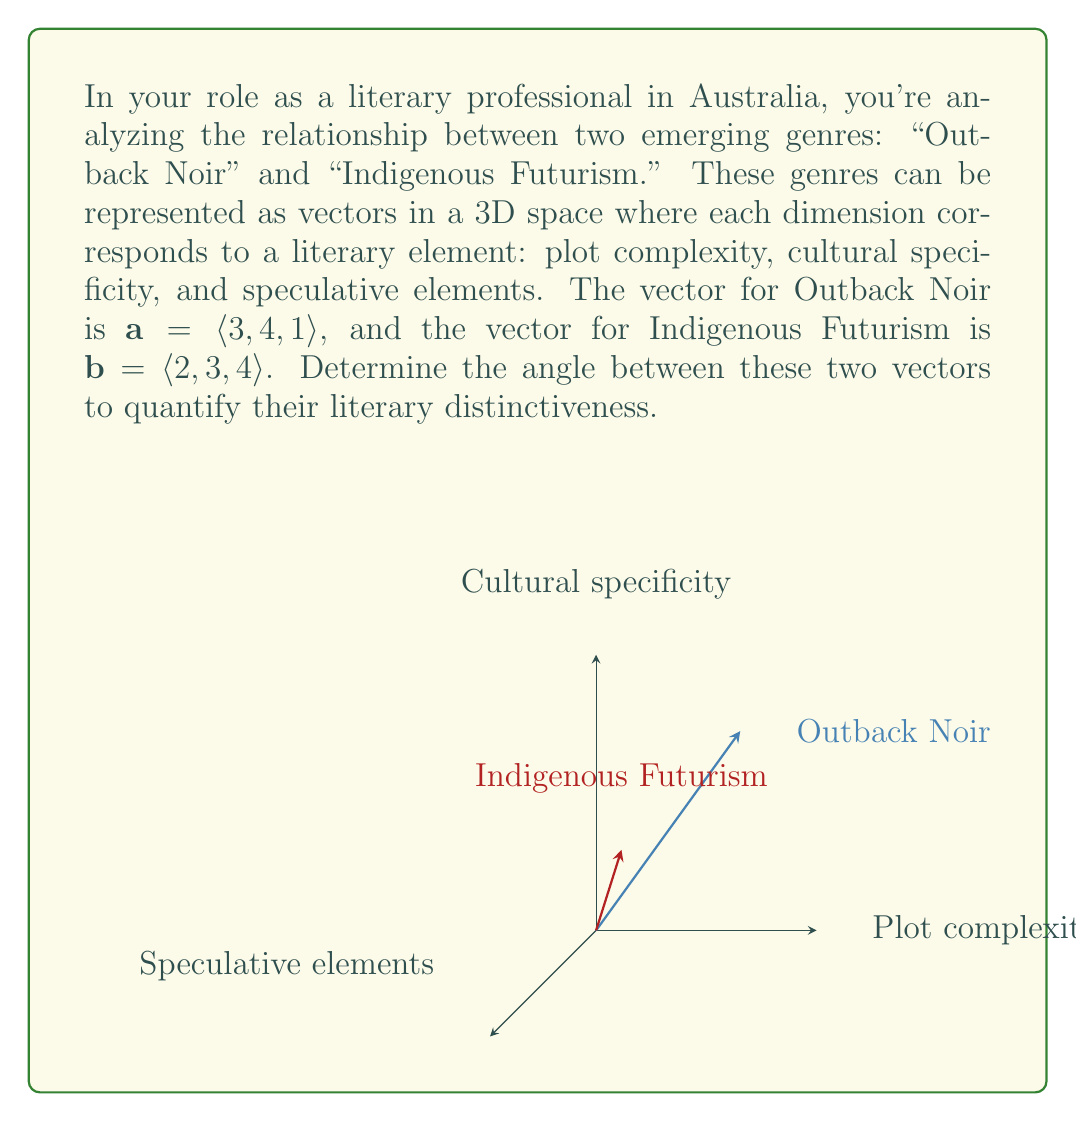Teach me how to tackle this problem. To find the angle between two vectors, we can use the dot product formula:

$$\cos \theta = \frac{\mathbf{a} \cdot \mathbf{b}}{|\mathbf{a}||\mathbf{b}|}$$

Step 1: Calculate the dot product $\mathbf{a} \cdot \mathbf{b}$
$$\mathbf{a} \cdot \mathbf{b} = (3)(2) + (4)(3) + (1)(4) = 6 + 12 + 4 = 22$$

Step 2: Calculate the magnitudes of vectors $\mathbf{a}$ and $\mathbf{b}$
$$|\mathbf{a}| = \sqrt{3^2 + 4^2 + 1^2} = \sqrt{9 + 16 + 1} = \sqrt{26}$$
$$|\mathbf{b}| = \sqrt{2^2 + 3^2 + 4^2} = \sqrt{4 + 9 + 16} = \sqrt{29}$$

Step 3: Apply the dot product formula
$$\cos \theta = \frac{22}{\sqrt{26}\sqrt{29}}$$

Step 4: Calculate the angle using the inverse cosine function
$$\theta = \arccos\left(\frac{22}{\sqrt{26}\sqrt{29}}\right)$$

Step 5: Convert to degrees
$$\theta = \arccos\left(\frac{22}{\sqrt{26}\sqrt{29}}\right) \cdot \frac{180°}{\pi} \approx 33.83°$$
Answer: $33.83°$ 